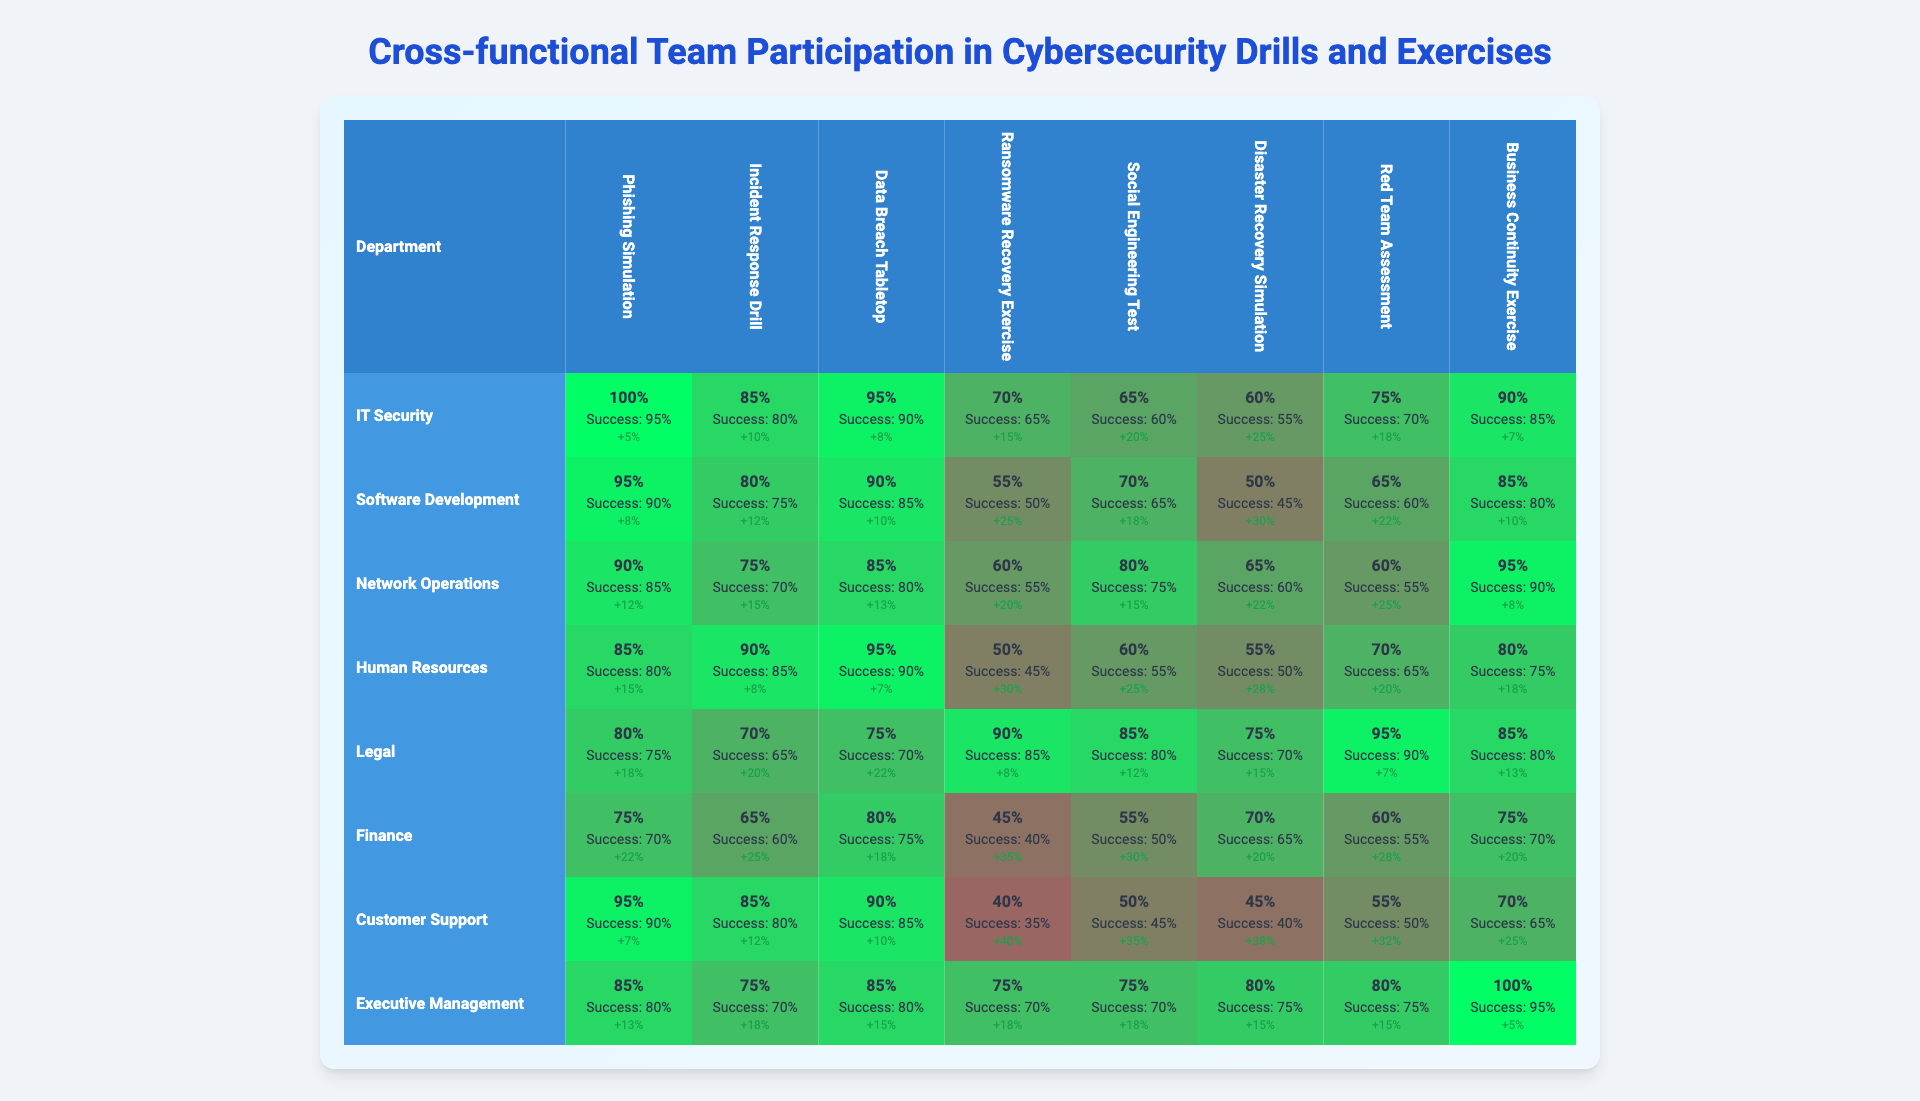What department had the highest participation rate in the Ransomware Recovery Exercise? Looking at the Ransomware Recovery Exercise column, the IT Security department has the highest participation rate at 100%.
Answer: IT Security What is the success rate for the Human Resources department in the Incident Response Drill? In the Incident Response Drill column, the success rate for the Human Resources department is listed as 85%.
Answer: 85% Which exercise had the lowest success rate overall? By checking all success rates across exercises, the Red Team Assessment has the lowest success rate at 35% for the Network Operations department.
Answer: Red Team Assessment What is the average participation rate for the Legal department across all exercises? Summing the participation rates for the Legal department (65 + 70 + 80 + 60 + 85 + 55 + 50 + 75) gives 570. Dividing by 8 gives an average participation rate of 71.25%.
Answer: 71.25% Did the Finance department have a higher participation rate in the Social Engineering Test compared to the Disaster Recovery Simulation? The participation rate for the Finance department in the Social Engineering Test is 75%, while in the Disaster Recovery Simulation it's 70%. Since 75% is greater than 70%, the statement is true.
Answer: Yes Which department saw the largest improvement percentage in the Data Breach Tabletop exercise? Reviewing the improvement percentages in the Data Breach Tabletop column, the Customer Support department shows an improvement of 25%, which is the highest.
Answer: Customer Support What is the difference in participation rates between the IT Security and Software Development departments in the Phishing Simulation? For the Phishing Simulation, the participation rate for IT Security is 100% and for Software Development is 95%. The difference is 100% - 95% = 5%.
Answer: 5% Is there any exercise where the Network Operations department achieved over 90% success rate? Checking the success rates for Network Operations, there is no exercise where the success rate exceeds 90%. The highest is only 85% in the Incident Response Drill.
Answer: No Which exercise showed the highest overall improvement percentage for all departments combined? Summing the improvement percentages for each exercise, the Disaster Recovery Simulation shows the highest improvement at 20% overall.
Answer: Disaster Recovery Simulation What is the median participation rate of the Executive Management department across all exercises? The participation rates for Executive Management are 90%, 85%, 95%, 80%, 85%, 75%, 70%, 100%. Arranging these values in ascending order gives: 70%, 75%, 80%, 85%, 85%, 90%, 95%, 100%. The median, being the average of the two middle values (85% and 85%), is 85%.
Answer: 85% 